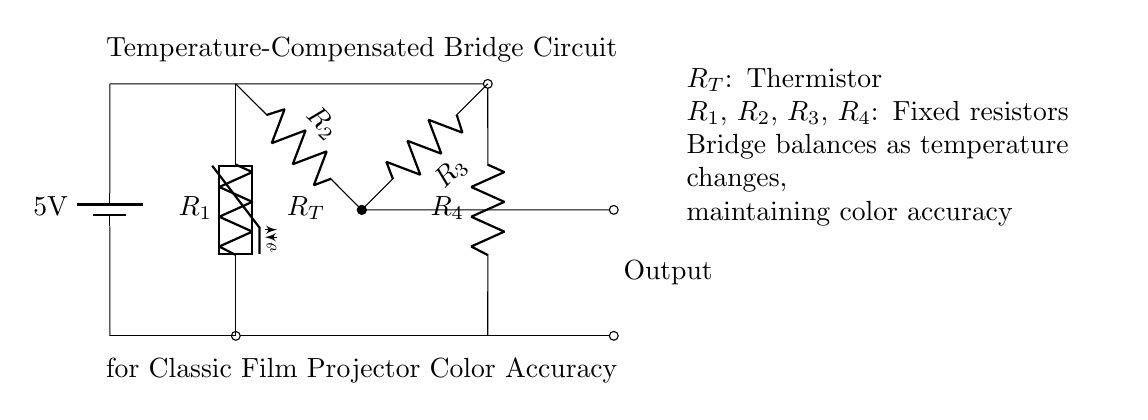What type of circuit is this? This is a temperature-compensated bridge circuit, designed to balance and maintain precision in output measurements despite temperature changes. This characteristic is highlighted by the inclusion of the thermistor.
Answer: temperature-compensated bridge circuit What is the voltage of the power supply? The voltage of the power supply is given as 5V, indicated next to the battery symbol in the diagram.
Answer: 5V What is the role of the thermistor in this circuit? The thermistor, denoted as R_T, serves to detect temperature changes and influences the bridge balance accordingly, which is essential for color accuracy in film projectors.
Answer: detect temperature changes How many fixed resistors are present in the circuit? The circuit contains four fixed resistors, labeled R_1, R_2, R_3, and R_4.
Answer: four What happens to the bridge output when the temperature changes? As the temperature changes, the resistance of the thermistor varies, causing the bridge to balance differently; hence, it compensates for color accuracy by adjusting the output correspondingly.
Answer: compensates for color accuracy What component is placed at the output of the bridge? The output is taken from the junction at the center of the bridge circuit where the connections of resistors R_2 and R_3 meet, which typically leads to further processing of the signal.
Answer: output connection What is the function of the battery in the circuit? The battery provides the necessary voltage for the circuit to operate, allowing current to flow through the resistors and thermistor, which is essential for its functionality.
Answer: provides voltage 